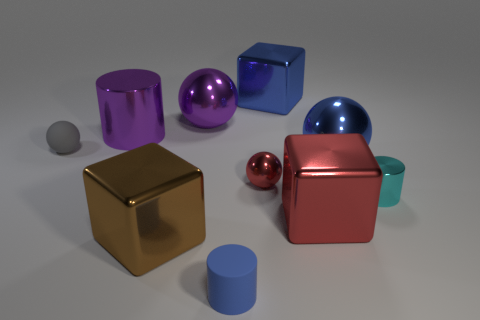Subtract all gray rubber spheres. How many spheres are left? 3 Add 9 yellow shiny spheres. How many yellow shiny spheres exist? 9 Subtract all blue cylinders. How many cylinders are left? 2 Subtract 0 cyan blocks. How many objects are left? 10 Subtract all cubes. How many objects are left? 7 Subtract 2 cylinders. How many cylinders are left? 1 Subtract all blue cylinders. Subtract all gray cubes. How many cylinders are left? 2 Subtract all green balls. How many cyan cylinders are left? 1 Subtract all tiny green cylinders. Subtract all small rubber cylinders. How many objects are left? 9 Add 5 brown shiny blocks. How many brown shiny blocks are left? 6 